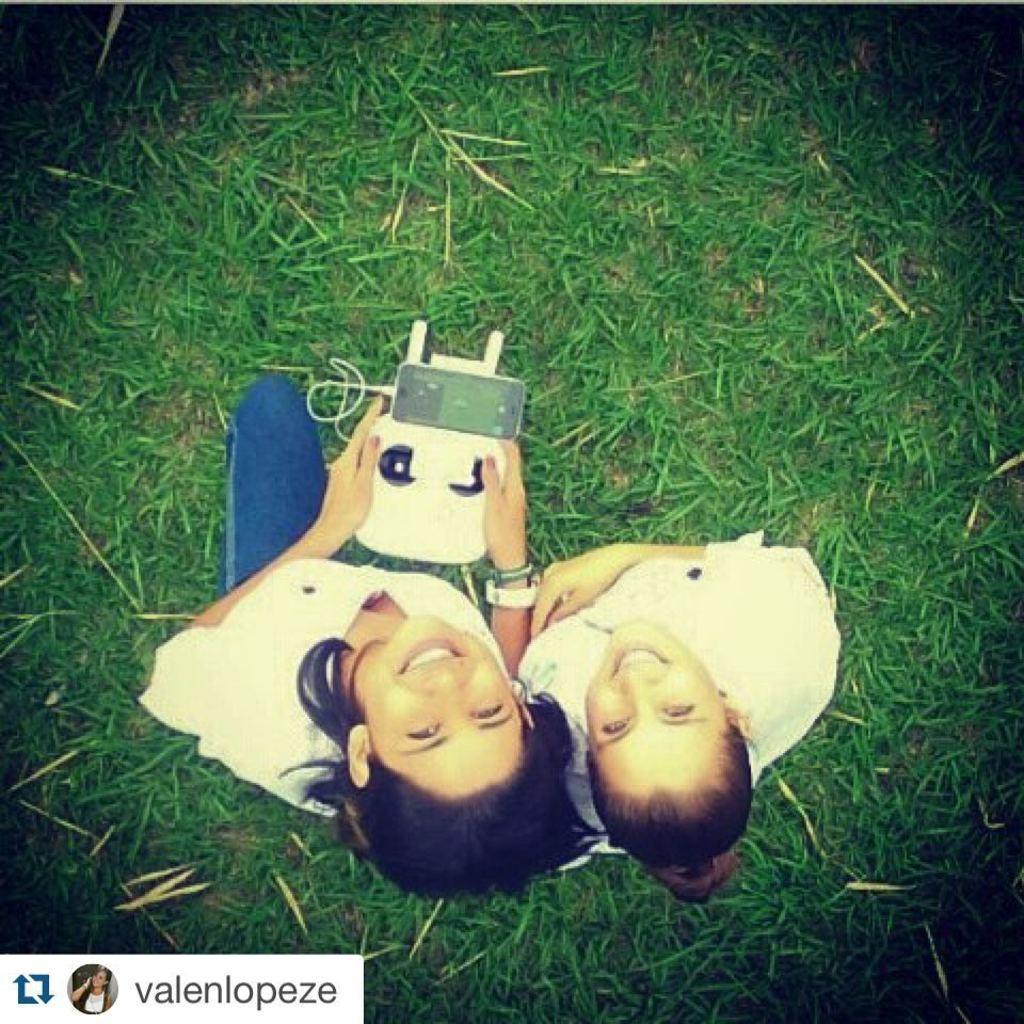In one or two sentences, can you explain what this image depicts? In the foreground of this image, there are two women on a grass and a woman is holding a gadget in her hand. 